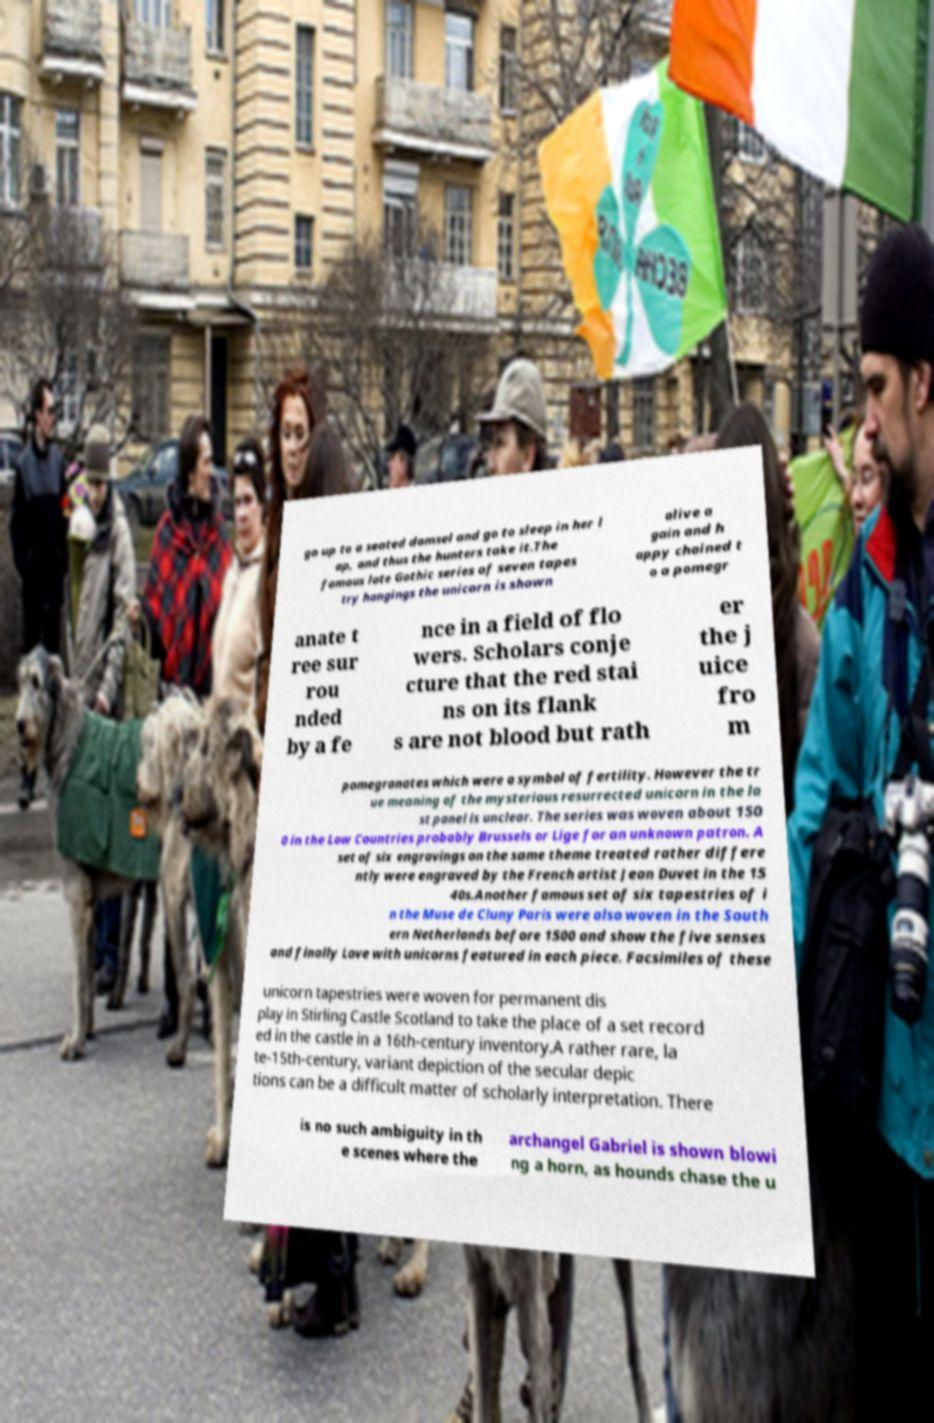For documentation purposes, I need the text within this image transcribed. Could you provide that? go up to a seated damsel and go to sleep in her l ap, and thus the hunters take it.The famous late Gothic series of seven tapes try hangings the unicorn is shown alive a gain and h appy chained t o a pomegr anate t ree sur rou nded by a fe nce in a field of flo wers. Scholars conje cture that the red stai ns on its flank s are not blood but rath er the j uice fro m pomegranates which were a symbol of fertility. However the tr ue meaning of the mysterious resurrected unicorn in the la st panel is unclear. The series was woven about 150 0 in the Low Countries probably Brussels or Lige for an unknown patron. A set of six engravings on the same theme treated rather differe ntly were engraved by the French artist Jean Duvet in the 15 40s.Another famous set of six tapestries of i n the Muse de Cluny Paris were also woven in the South ern Netherlands before 1500 and show the five senses and finally Love with unicorns featured in each piece. Facsimiles of these unicorn tapestries were woven for permanent dis play in Stirling Castle Scotland to take the place of a set record ed in the castle in a 16th-century inventory.A rather rare, la te-15th-century, variant depiction of the secular depic tions can be a difficult matter of scholarly interpretation. There is no such ambiguity in th e scenes where the archangel Gabriel is shown blowi ng a horn, as hounds chase the u 